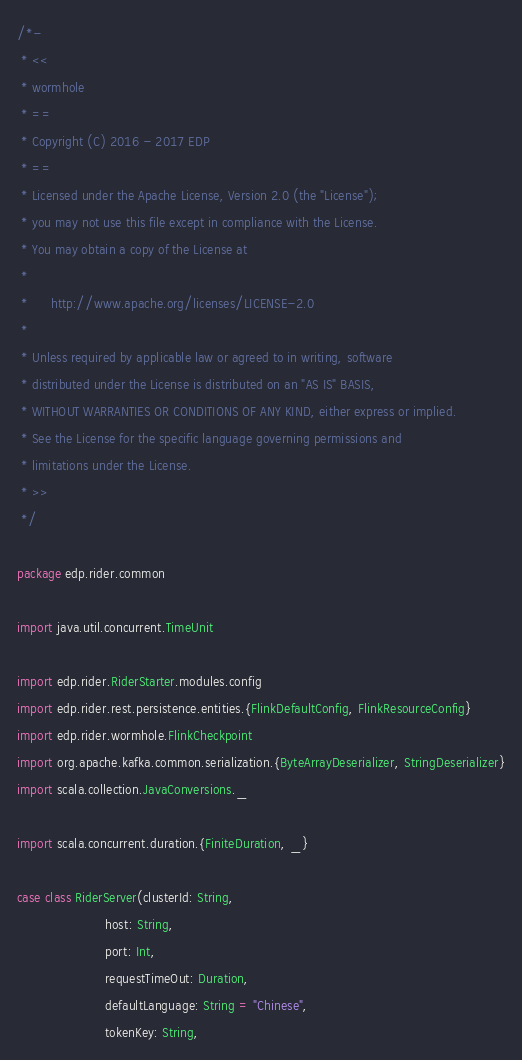Convert code to text. <code><loc_0><loc_0><loc_500><loc_500><_Scala_>/*-
 * <<
 * wormhole
 * ==
 * Copyright (C) 2016 - 2017 EDP
 * ==
 * Licensed under the Apache License, Version 2.0 (the "License");
 * you may not use this file except in compliance with the License.
 * You may obtain a copy of the License at
 * 
 *      http://www.apache.org/licenses/LICENSE-2.0
 * 
 * Unless required by applicable law or agreed to in writing, software
 * distributed under the License is distributed on an "AS IS" BASIS,
 * WITHOUT WARRANTIES OR CONDITIONS OF ANY KIND, either express or implied.
 * See the License for the specific language governing permissions and
 * limitations under the License.
 * >>
 */

package edp.rider.common

import java.util.concurrent.TimeUnit

import edp.rider.RiderStarter.modules.config
import edp.rider.rest.persistence.entities.{FlinkDefaultConfig, FlinkResourceConfig}
import edp.rider.wormhole.FlinkCheckpoint
import org.apache.kafka.common.serialization.{ByteArrayDeserializer, StringDeserializer}
import scala.collection.JavaConversions._

import scala.concurrent.duration.{FiniteDuration, _}

case class RiderServer(clusterId: String,
                       host: String,
                       port: Int,
                       requestTimeOut: Duration,
                       defaultLanguage: String = "Chinese",
                       tokenKey: String,</code> 